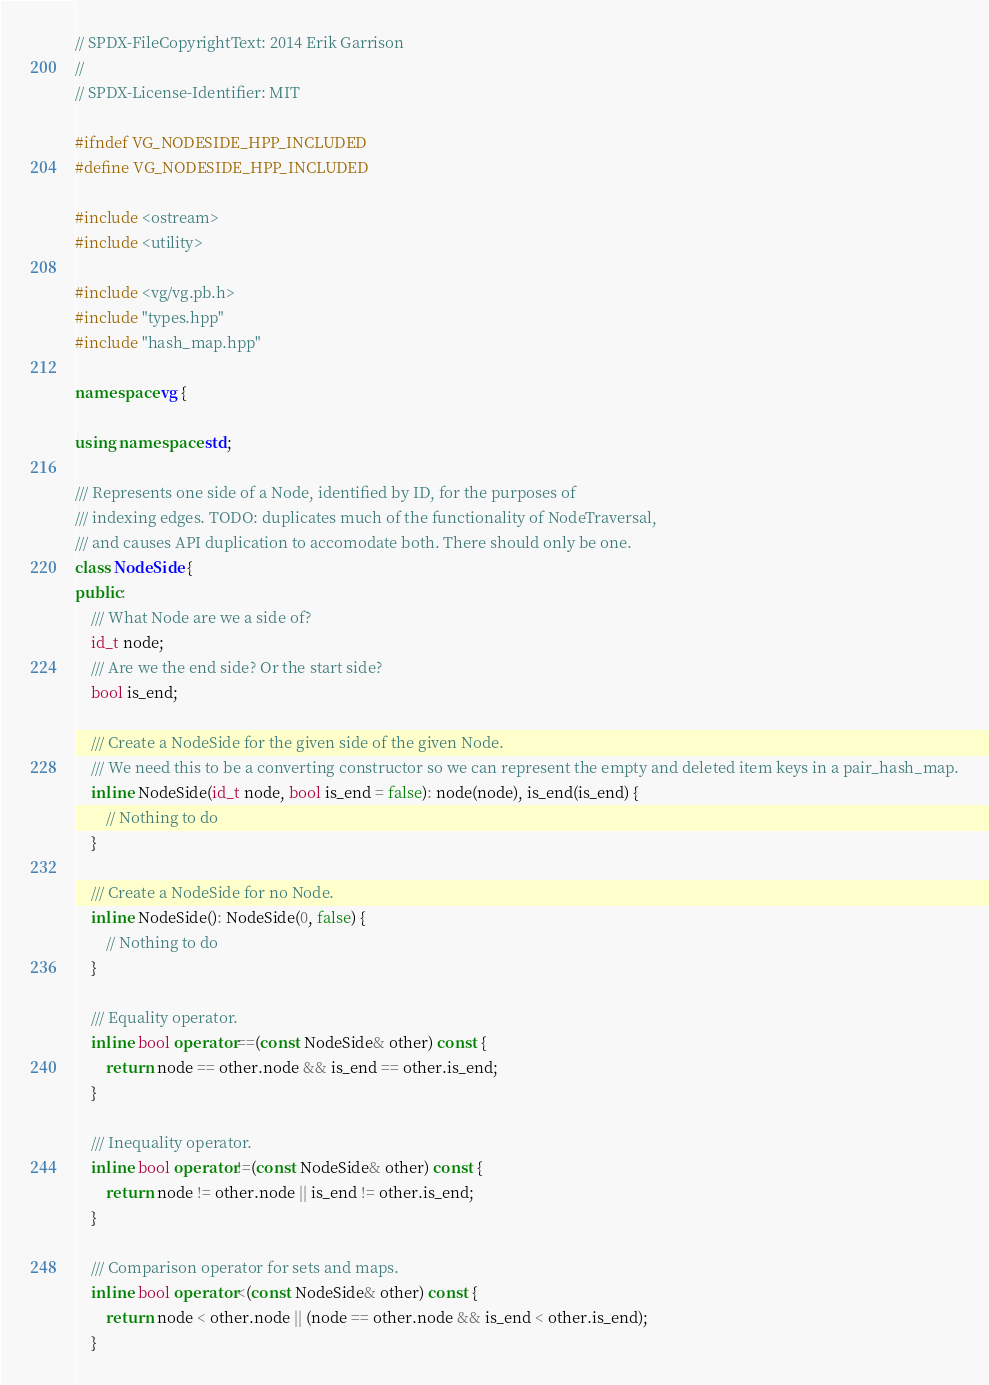Convert code to text. <code><loc_0><loc_0><loc_500><loc_500><_C++_>// SPDX-FileCopyrightText: 2014 Erik Garrison
//
// SPDX-License-Identifier: MIT

#ifndef VG_NODESIDE_HPP_INCLUDED
#define VG_NODESIDE_HPP_INCLUDED

#include <ostream>
#include <utility>

#include <vg/vg.pb.h>
#include "types.hpp"
#include "hash_map.hpp"

namespace vg {

using namespace std;

/// Represents one side of a Node, identified by ID, for the purposes of
/// indexing edges. TODO: duplicates much of the functionality of NodeTraversal,
/// and causes API duplication to accomodate both. There should only be one.
class NodeSide {
public:
    /// What Node are we a side of?
    id_t node;
    /// Are we the end side? Or the start side?
    bool is_end;

    /// Create a NodeSide for the given side of the given Node.
    /// We need this to be a converting constructor so we can represent the empty and deleted item keys in a pair_hash_map.
    inline NodeSide(id_t node, bool is_end = false): node(node), is_end(is_end) {
        // Nothing to do
    }

    /// Create a NodeSide for no Node.
    inline NodeSide(): NodeSide(0, false) {
        // Nothing to do
    }

    /// Equality operator.
    inline bool operator==(const NodeSide& other) const {
        return node == other.node && is_end == other.is_end;
    }

    /// Inequality operator.
    inline bool operator!=(const NodeSide& other) const {
        return node != other.node || is_end != other.is_end;
    }

    /// Comparison operator for sets and maps.
    inline bool operator<(const NodeSide& other) const {
        return node < other.node || (node == other.node && is_end < other.is_end);
    }
</code> 